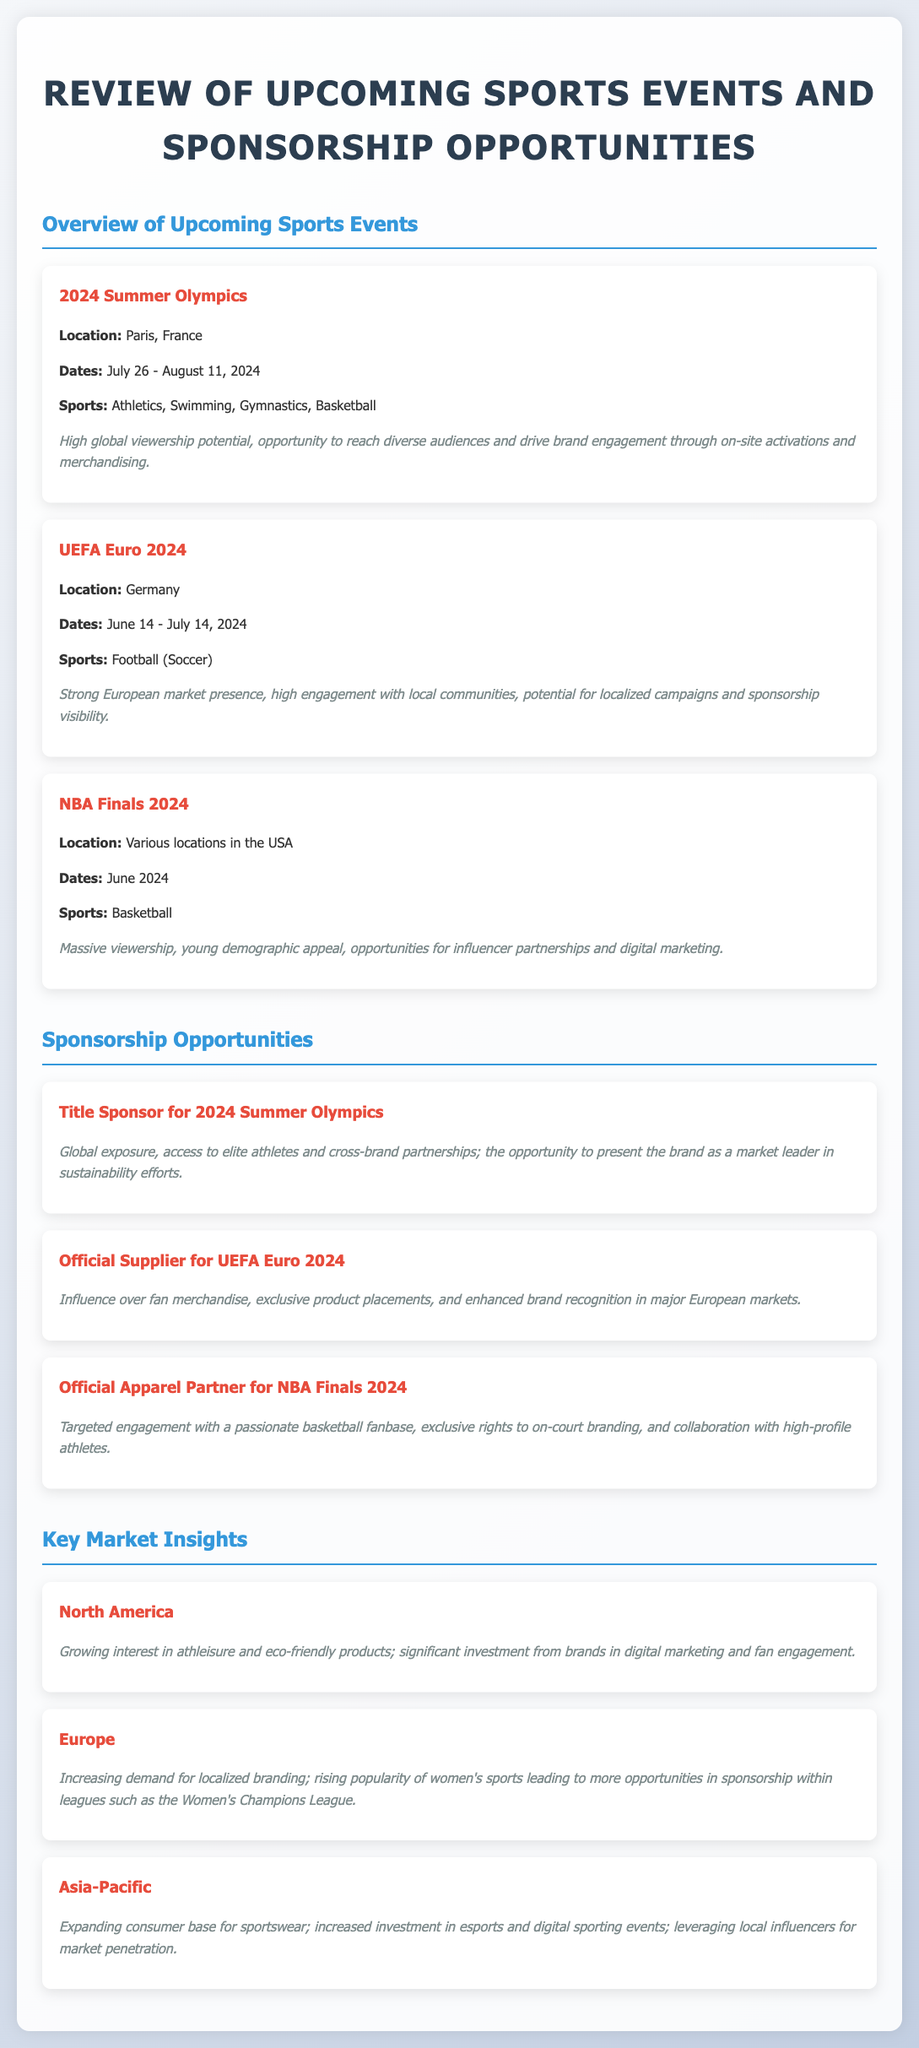What are the dates of the UEFA Euro 2024? The document specifies that UEFA Euro 2024 will occur from June 14 to July 14, 2024.
Answer: June 14 - July 14, 2024 Where will the 2024 Summer Olympics be held? The document states that the location for the 2024 Summer Olympics is Paris, France.
Answer: Paris, France What is one sport featured in the NBA Finals 2024? The only sport mentioned for the NBA Finals 2024 in the document is basketball.
Answer: Basketball What is a key market trend in North America? The document highlights that there is a growing interest in athleisure and eco-friendly products in North America.
Answer: Growing interest in athleisure and eco-friendly products What is the benefit of being a Title Sponsor for the 2024 Summer Olympics? The document outlines that global exposure is a key benefit of being a Title Sponsor for the 2024 Summer Olympics.
Answer: Global exposure Why is the UEFA Euro 2024 a strong sponsorship opportunity? The document mentions that UEFA Euro 2024 offers high engagement with local communities as a sponsorship opportunity.
Answer: High engagement with local communities What is the sportswear market trend in the Asia-Pacific region? The document indicates that there is an expanding consumer base for sportswear in the Asia-Pacific region.
Answer: Expanding consumer base for sportswear Which women's sports league is gaining popularity in Europe? The document points out the rising popularity of the Women's Champions League in Europe.
Answer: Women's Champions League 